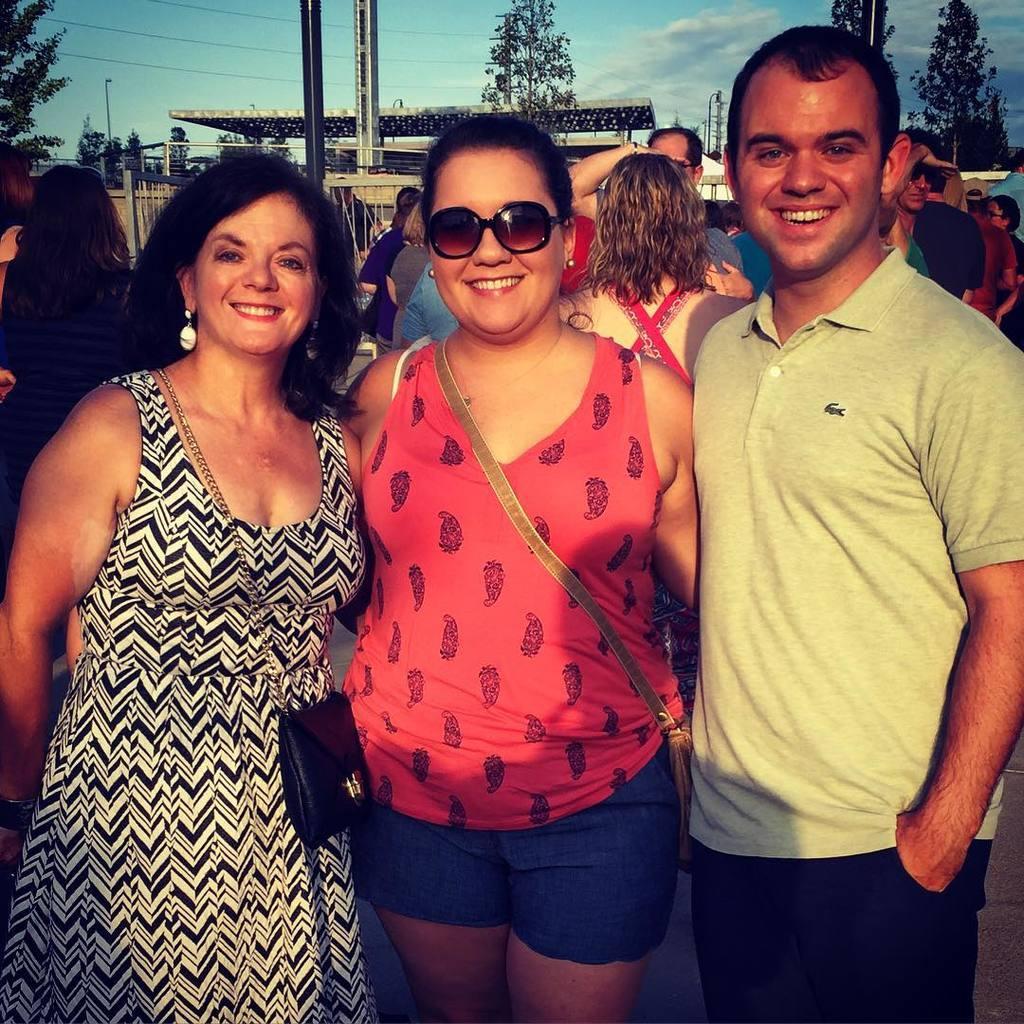In one or two sentences, can you explain what this image depicts? In this image there are two women and women are posing to a photograph, in the back there are people, in the background there trees and a sky. 